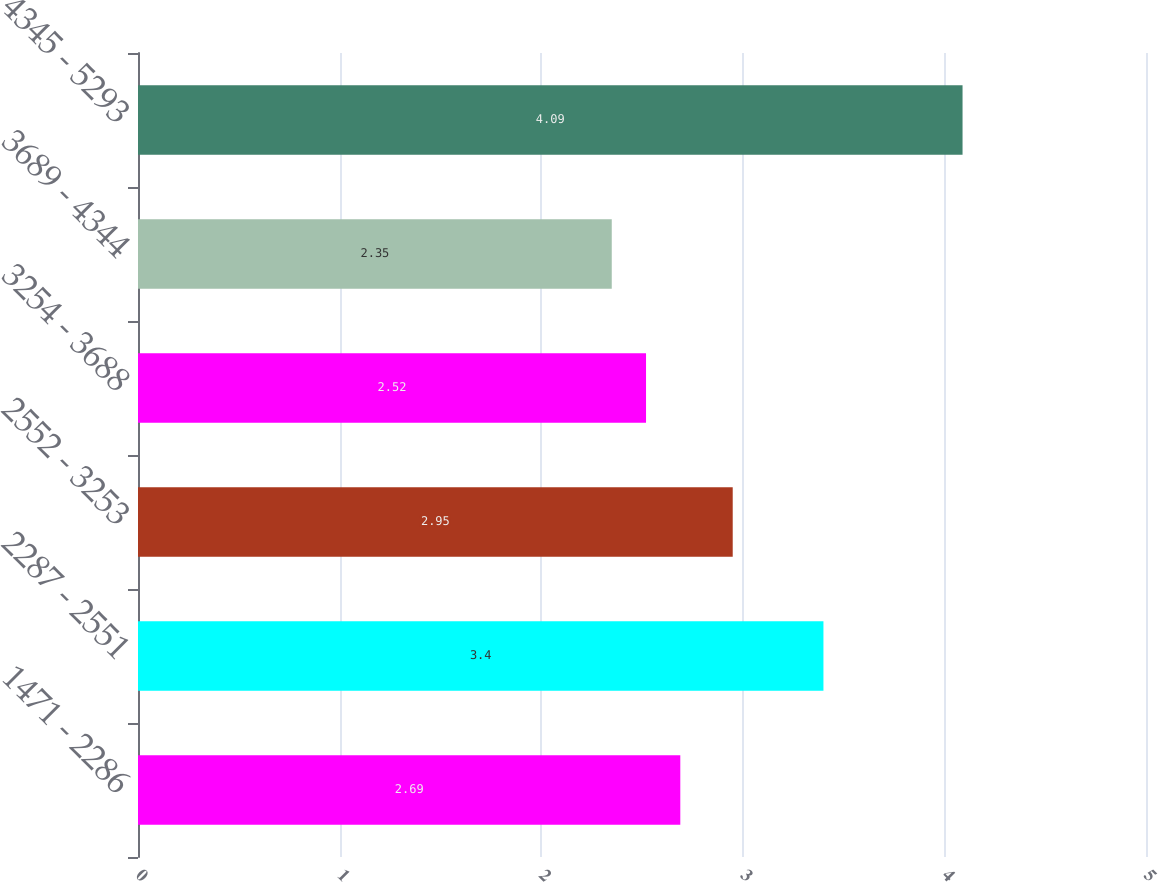Convert chart. <chart><loc_0><loc_0><loc_500><loc_500><bar_chart><fcel>1471 - 2286<fcel>2287 - 2551<fcel>2552 - 3253<fcel>3254 - 3688<fcel>3689 - 4344<fcel>4345 - 5293<nl><fcel>2.69<fcel>3.4<fcel>2.95<fcel>2.52<fcel>2.35<fcel>4.09<nl></chart> 